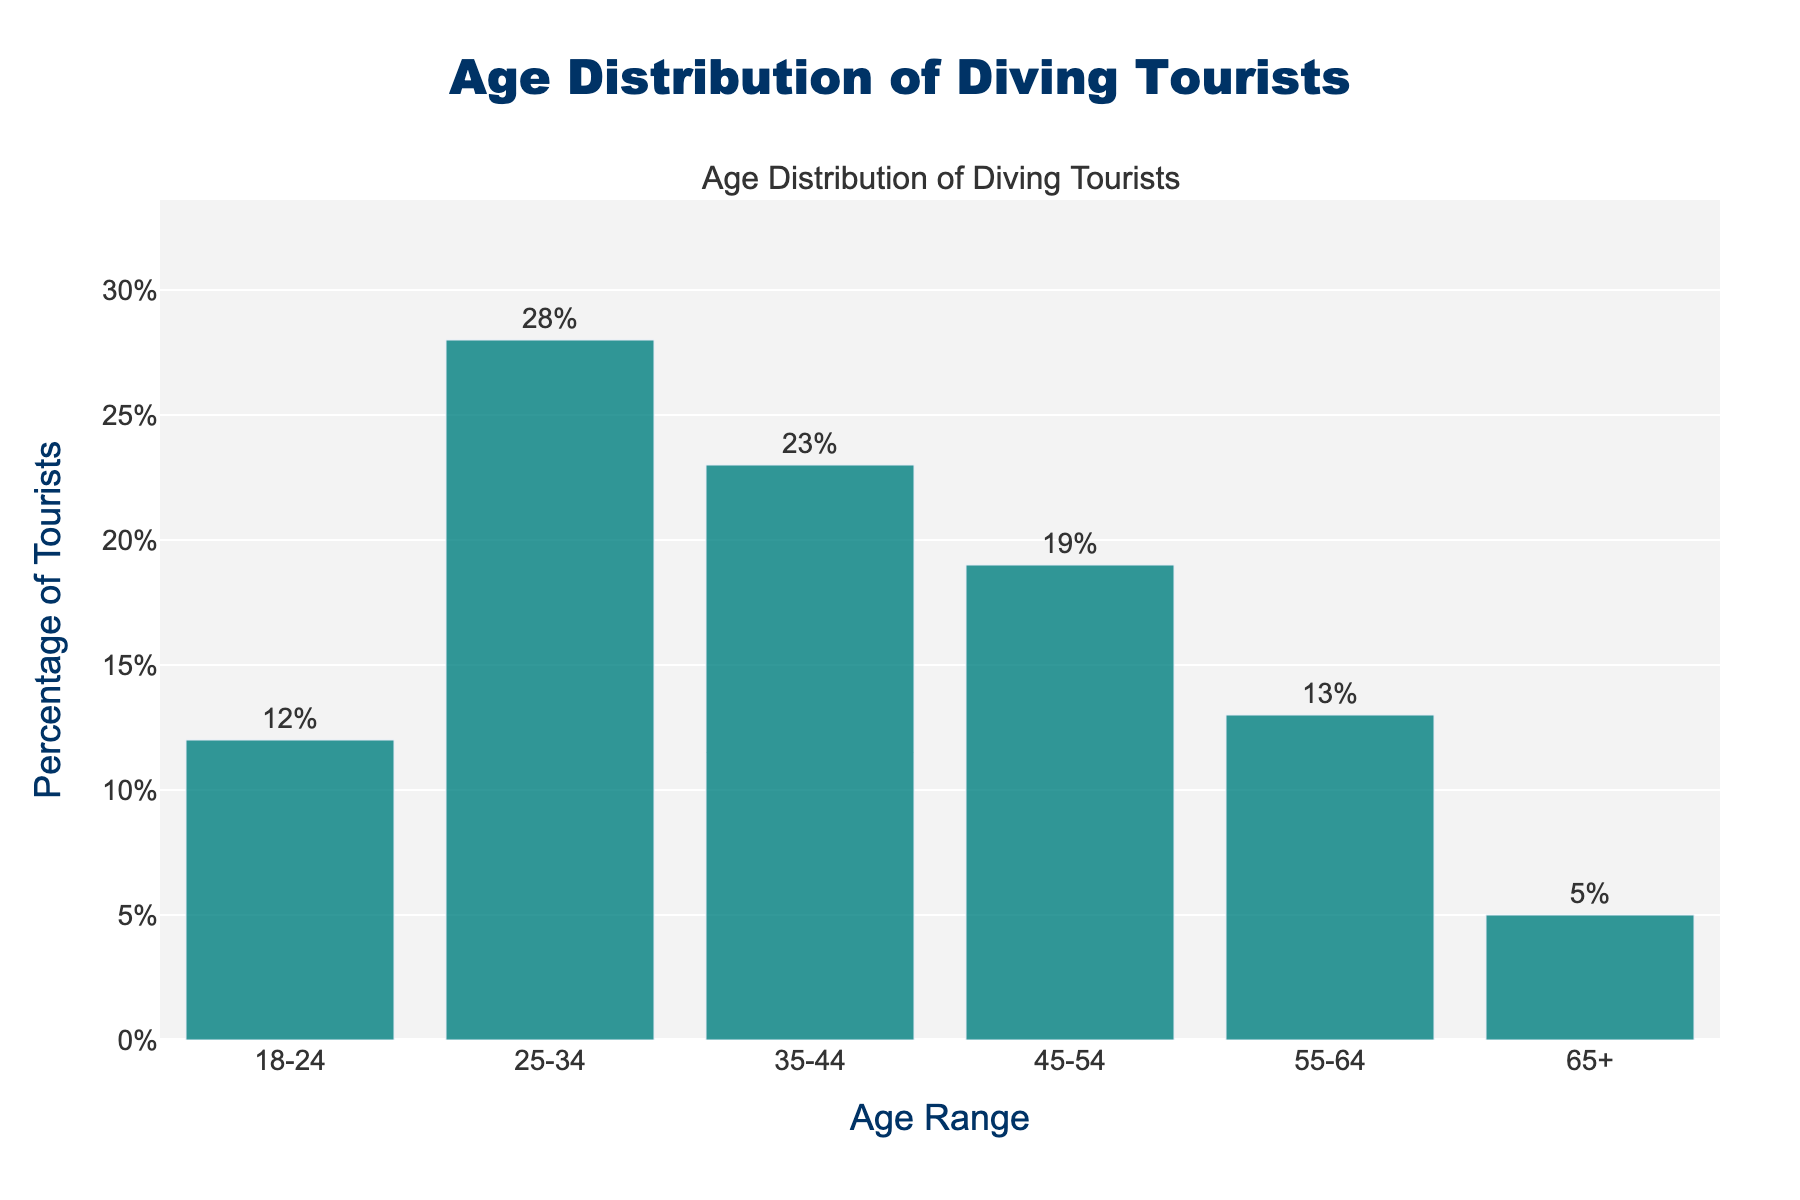What is the most common age range for diving tourists? The highest bar in the chart represents the age range 25-34. The percentage for this age range is the highest at 28%.
Answer: 25-34 Which age group has the smallest percentage of diving tourists? The smallest bar according to height and the number labeled outside is the 65+ age range with a 5% share.
Answer: 65+ What is the combined percentage of diving tourists in the age ranges 35-44 and 45-54? Adding the percentages of 35-44 (23%) and 45-54 (19%), we get 23% + 19% = 42%.
Answer: 42% How much more popular is the age range 25-34 compared to 18-24? Subtract the percentage of 18-24 (12%) from 25-34 (28%), which is 28% - 12% = 16%.
Answer: 16% Which age range has a percentage closest to the average percentage of all age ranges? Calculate the average of all percentages: (12% + 28% + 23% + 19% + 13% + 5%) / 6 ≈ 16.67%. The closest to 16.67% is 18-24 with 12% and 55-64 with 13%.
Answer: 18-24 and 55-64 What is the total percentage of tourists aged 55 and above? Add the percentages of the age ranges 55-64 (13%) and 65+ (5%), which is 13% + 5% = 18%.
Answer: 18% Are there more tourists in the age range 45-54 than in 35-44? Comparing the heights and values, the percentage of 35-44 is 23% and for 45-54 is 19%. Thus, 35-44 has more tourists.
Answer: No What is the percentage difference between the oldest and youngest age ranges? The percentage for the oldest age range (65+) is 5%, and for the youngest age range (18-24) is 12%. The difference is 12% - 5% = 7%.
Answer: 7% How does the percentage of tourists aged 25-34 compare to the sum of tourists aged 45-54 and 55-64? The percentage for 25-34 is 28%, and the sum of 45-54 (19%) and 55-64 (13%) is 19% + 13% = 32%. Therefore, 25-34 is 4% less.
Answer: Less by 4% Between which two consecutive age ranges is the biggest drop in percentage observed? Compare the differences between consecutive age ranges: (28%-12%=16%), (28%-23%=5%), (23%-19%=4%), (19%-13%=6%), (13%-5%=8%). The biggest drop is between 55-64 and 65+.
Answer: 55-64 and 65+ 